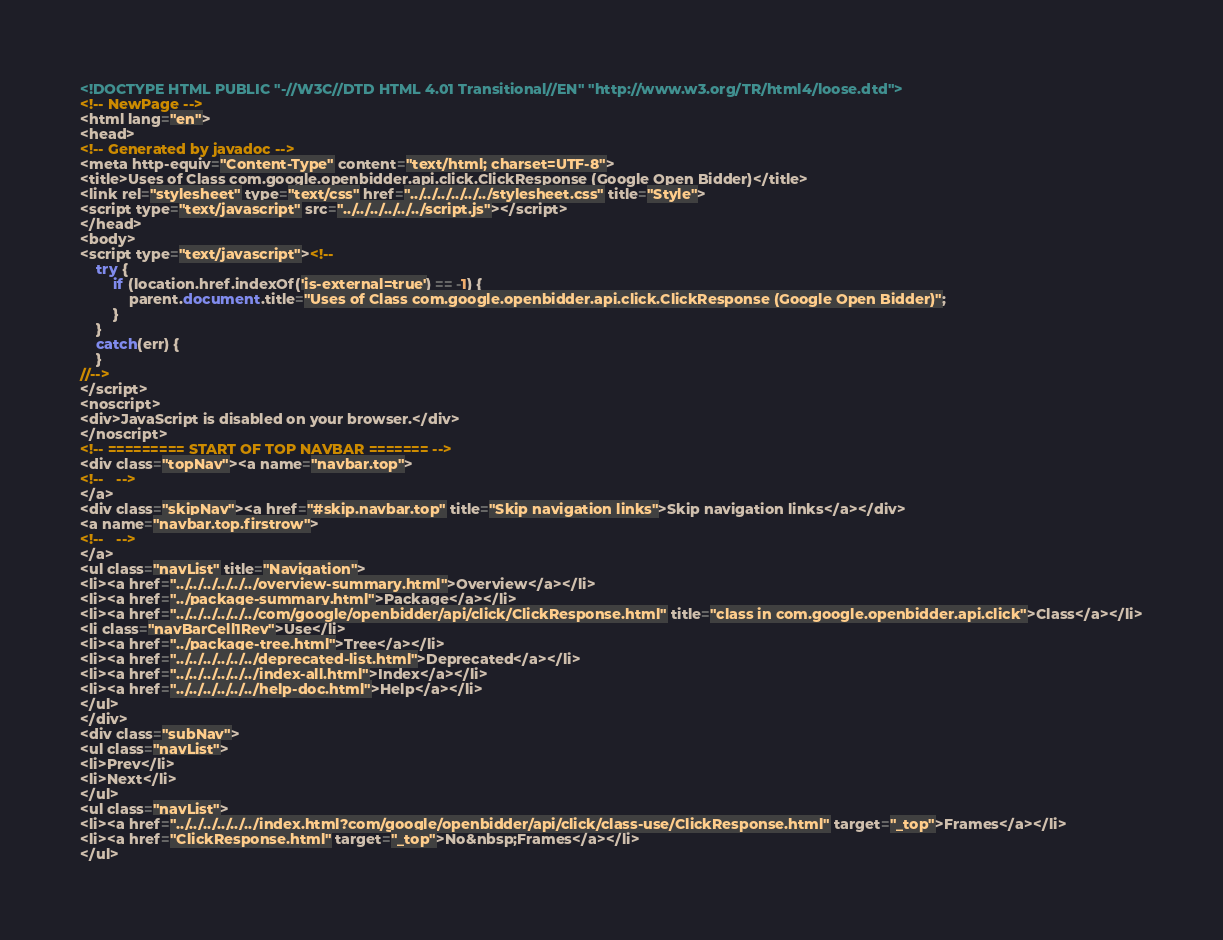Convert code to text. <code><loc_0><loc_0><loc_500><loc_500><_HTML_><!DOCTYPE HTML PUBLIC "-//W3C//DTD HTML 4.01 Transitional//EN" "http://www.w3.org/TR/html4/loose.dtd">
<!-- NewPage -->
<html lang="en">
<head>
<!-- Generated by javadoc -->
<meta http-equiv="Content-Type" content="text/html; charset=UTF-8">
<title>Uses of Class com.google.openbidder.api.click.ClickResponse (Google Open Bidder)</title>
<link rel="stylesheet" type="text/css" href="../../../../../../stylesheet.css" title="Style">
<script type="text/javascript" src="../../../../../../script.js"></script>
</head>
<body>
<script type="text/javascript"><!--
    try {
        if (location.href.indexOf('is-external=true') == -1) {
            parent.document.title="Uses of Class com.google.openbidder.api.click.ClickResponse (Google Open Bidder)";
        }
    }
    catch(err) {
    }
//-->
</script>
<noscript>
<div>JavaScript is disabled on your browser.</div>
</noscript>
<!-- ========= START OF TOP NAVBAR ======= -->
<div class="topNav"><a name="navbar.top">
<!--   -->
</a>
<div class="skipNav"><a href="#skip.navbar.top" title="Skip navigation links">Skip navigation links</a></div>
<a name="navbar.top.firstrow">
<!--   -->
</a>
<ul class="navList" title="Navigation">
<li><a href="../../../../../../overview-summary.html">Overview</a></li>
<li><a href="../package-summary.html">Package</a></li>
<li><a href="../../../../../../com/google/openbidder/api/click/ClickResponse.html" title="class in com.google.openbidder.api.click">Class</a></li>
<li class="navBarCell1Rev">Use</li>
<li><a href="../package-tree.html">Tree</a></li>
<li><a href="../../../../../../deprecated-list.html">Deprecated</a></li>
<li><a href="../../../../../../index-all.html">Index</a></li>
<li><a href="../../../../../../help-doc.html">Help</a></li>
</ul>
</div>
<div class="subNav">
<ul class="navList">
<li>Prev</li>
<li>Next</li>
</ul>
<ul class="navList">
<li><a href="../../../../../../index.html?com/google/openbidder/api/click/class-use/ClickResponse.html" target="_top">Frames</a></li>
<li><a href="ClickResponse.html" target="_top">No&nbsp;Frames</a></li>
</ul></code> 